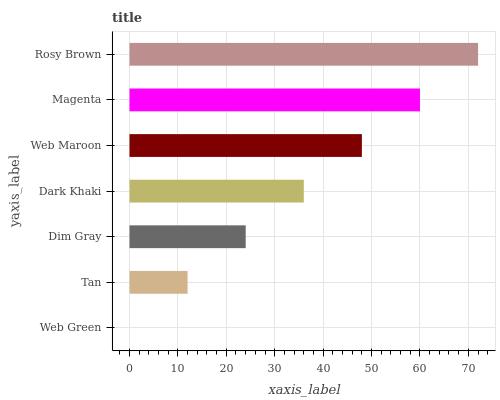Is Web Green the minimum?
Answer yes or no. Yes. Is Rosy Brown the maximum?
Answer yes or no. Yes. Is Tan the minimum?
Answer yes or no. No. Is Tan the maximum?
Answer yes or no. No. Is Tan greater than Web Green?
Answer yes or no. Yes. Is Web Green less than Tan?
Answer yes or no. Yes. Is Web Green greater than Tan?
Answer yes or no. No. Is Tan less than Web Green?
Answer yes or no. No. Is Dark Khaki the high median?
Answer yes or no. Yes. Is Dark Khaki the low median?
Answer yes or no. Yes. Is Tan the high median?
Answer yes or no. No. Is Tan the low median?
Answer yes or no. No. 